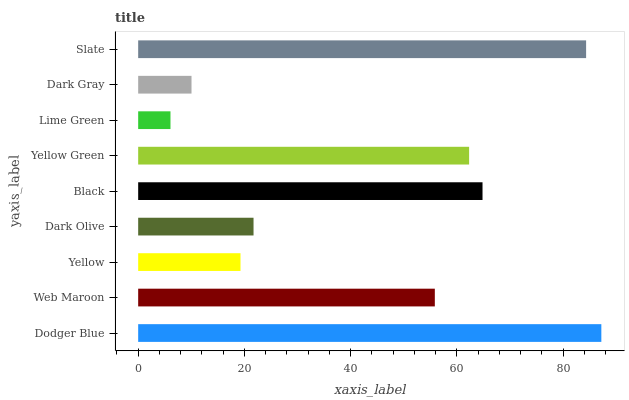Is Lime Green the minimum?
Answer yes or no. Yes. Is Dodger Blue the maximum?
Answer yes or no. Yes. Is Web Maroon the minimum?
Answer yes or no. No. Is Web Maroon the maximum?
Answer yes or no. No. Is Dodger Blue greater than Web Maroon?
Answer yes or no. Yes. Is Web Maroon less than Dodger Blue?
Answer yes or no. Yes. Is Web Maroon greater than Dodger Blue?
Answer yes or no. No. Is Dodger Blue less than Web Maroon?
Answer yes or no. No. Is Web Maroon the high median?
Answer yes or no. Yes. Is Web Maroon the low median?
Answer yes or no. Yes. Is Dodger Blue the high median?
Answer yes or no. No. Is Yellow the low median?
Answer yes or no. No. 